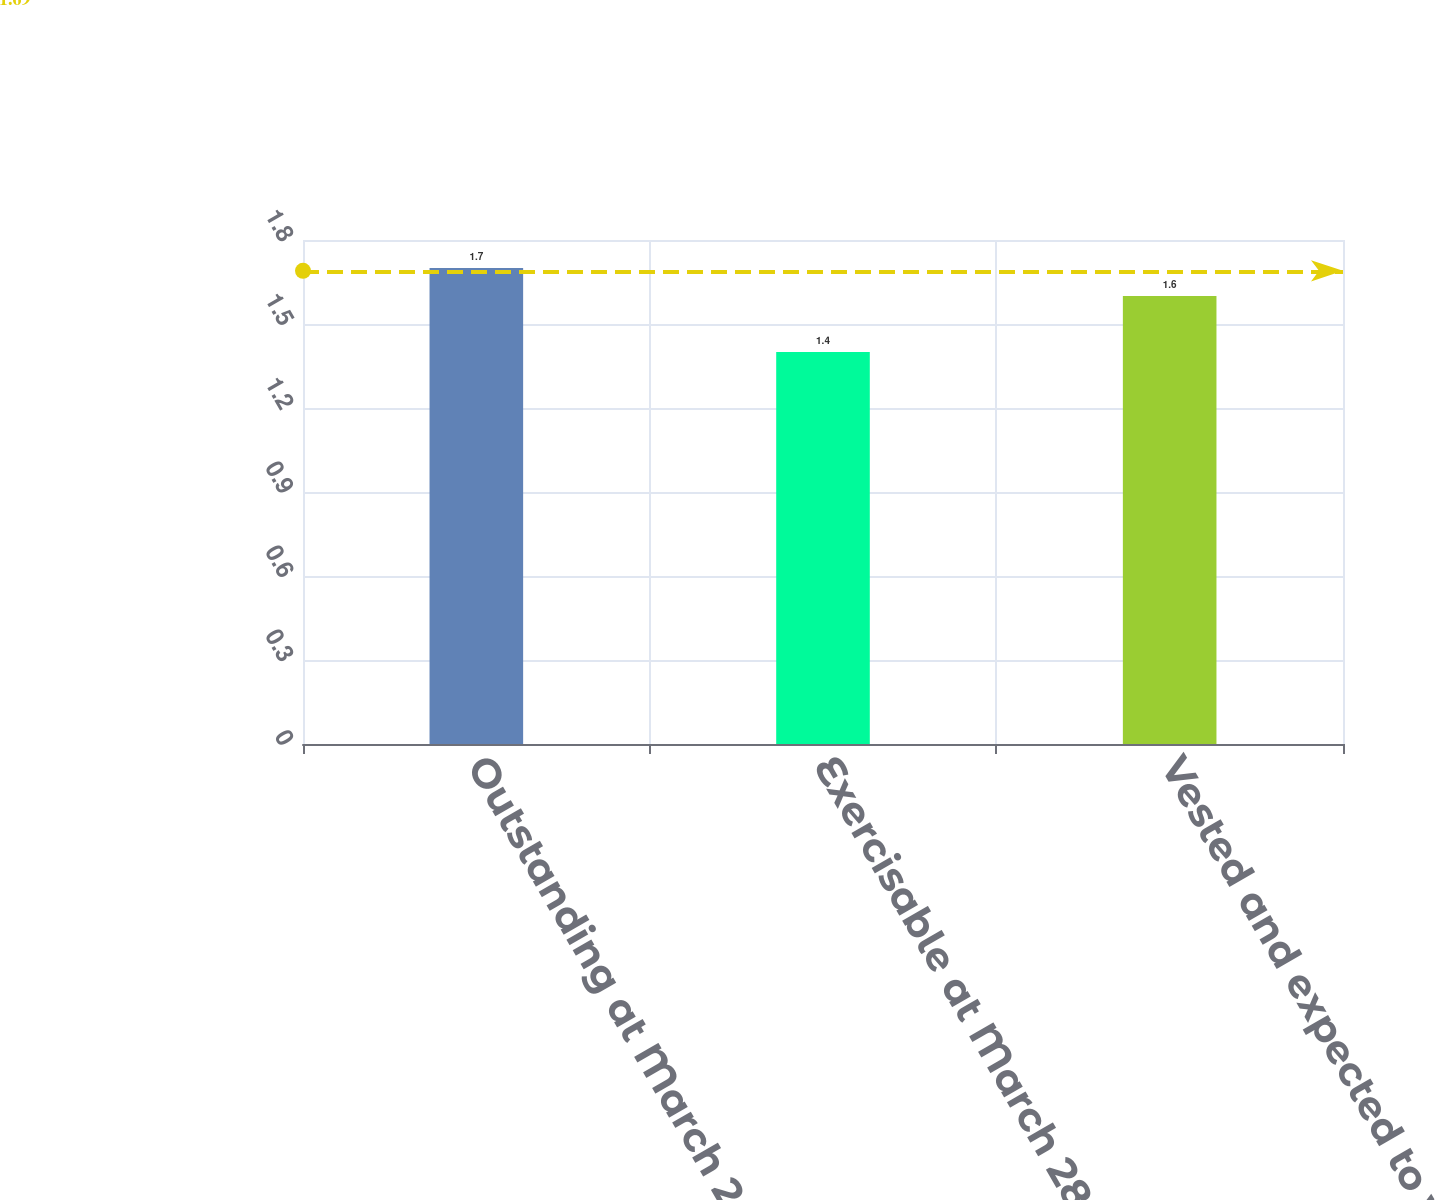<chart> <loc_0><loc_0><loc_500><loc_500><bar_chart><fcel>Outstanding at March 28 2014<fcel>Exercisable at March 28 2014<fcel>Vested and expected to vest at<nl><fcel>1.7<fcel>1.4<fcel>1.6<nl></chart> 